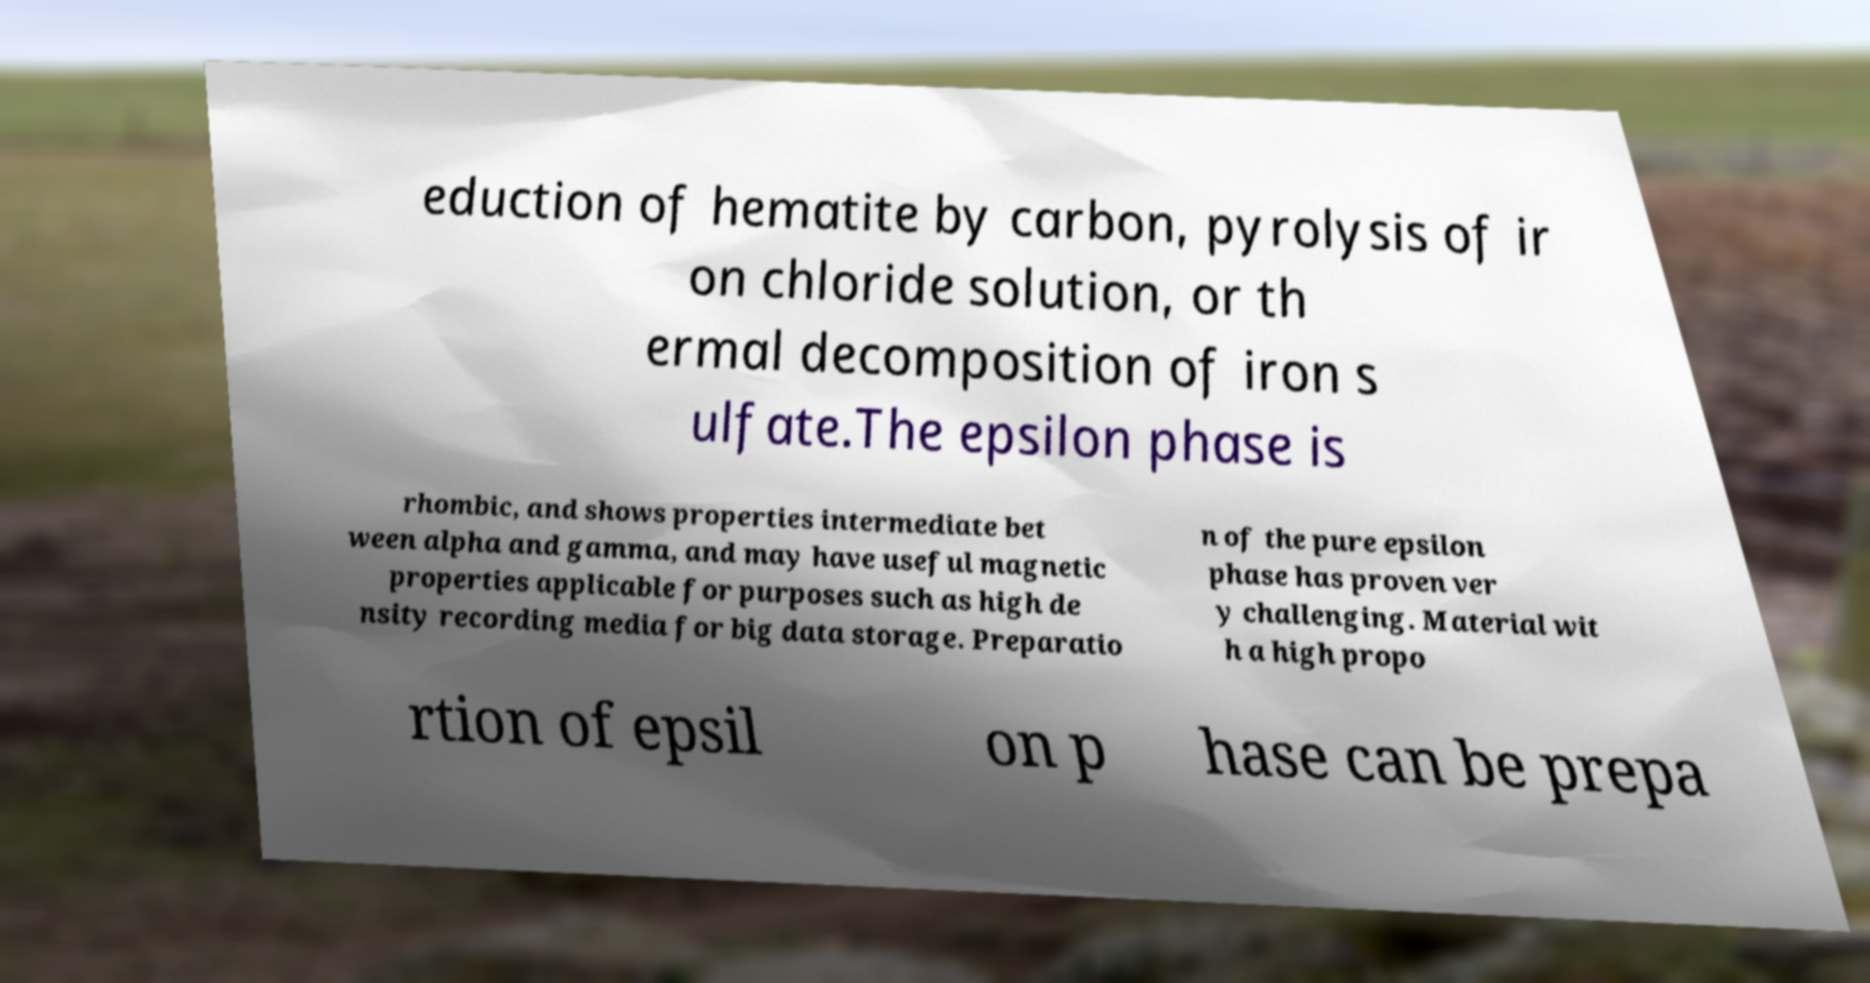Please identify and transcribe the text found in this image. eduction of hematite by carbon, pyrolysis of ir on chloride solution, or th ermal decomposition of iron s ulfate.The epsilon phase is rhombic, and shows properties intermediate bet ween alpha and gamma, and may have useful magnetic properties applicable for purposes such as high de nsity recording media for big data storage. Preparatio n of the pure epsilon phase has proven ver y challenging. Material wit h a high propo rtion of epsil on p hase can be prepa 